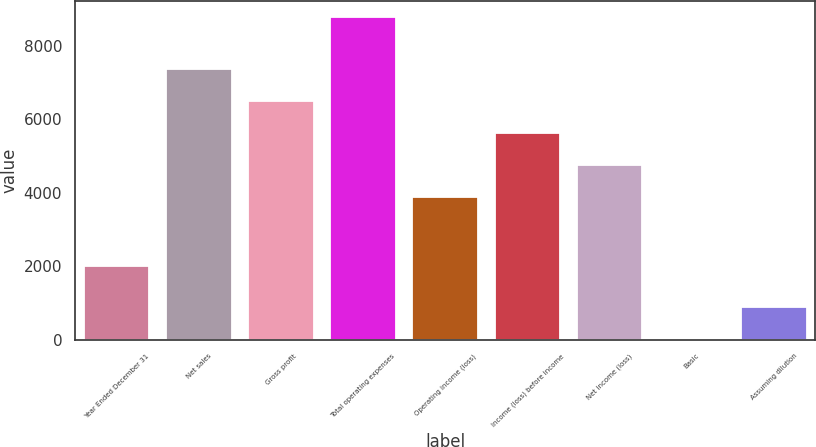Convert chart to OTSL. <chart><loc_0><loc_0><loc_500><loc_500><bar_chart><fcel>Year Ended December 31<fcel>Net sales<fcel>Gross profit<fcel>Total operating expenses<fcel>Operating income (loss)<fcel>Income (loss) before income<fcel>Net income (loss)<fcel>Basic<fcel>Assuming dilution<nl><fcel>2012<fcel>7374.04<fcel>6497.53<fcel>8768<fcel>3868<fcel>5621.02<fcel>4744.51<fcel>2.89<fcel>879.4<nl></chart> 